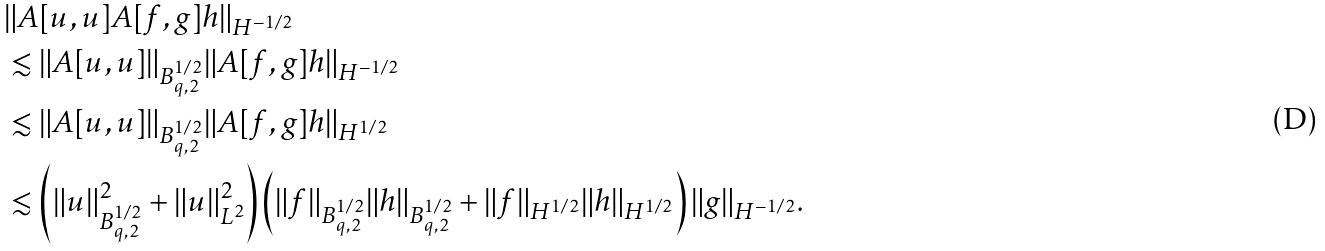Convert formula to latex. <formula><loc_0><loc_0><loc_500><loc_500>& \| A [ u , u ] A [ f , g ] h \| _ { H ^ { - 1 / 2 } } \\ & \lesssim \| A [ u , u ] \| _ { B ^ { 1 / 2 } _ { q , 2 } } \| A [ f , g ] h \| _ { H ^ { - 1 / 2 } } \\ & \lesssim \| A [ u , u ] \| _ { B ^ { 1 / 2 } _ { q , 2 } } \| A [ f , g ] h \| _ { H ^ { 1 / 2 } } \\ & \lesssim \left ( \| u \| _ { B ^ { 1 / 2 } _ { q , 2 } } ^ { 2 } + \| u \| _ { L ^ { 2 } } ^ { 2 } \right ) \left ( \| f \| _ { B ^ { 1 / 2 } _ { q , 2 } } \| h \| _ { B ^ { 1 / 2 } _ { q , 2 } } + \| f \| _ { H ^ { 1 / 2 } } \| h \| _ { H ^ { 1 / 2 } } \right ) \| g \| _ { H ^ { - 1 / 2 } } .</formula> 